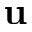Convert formula to latex. <formula><loc_0><loc_0><loc_500><loc_500>u</formula> 